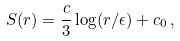Convert formula to latex. <formula><loc_0><loc_0><loc_500><loc_500>S ( r ) = \frac { c } { 3 } \log ( r / \epsilon ) + c _ { 0 } \, ,</formula> 